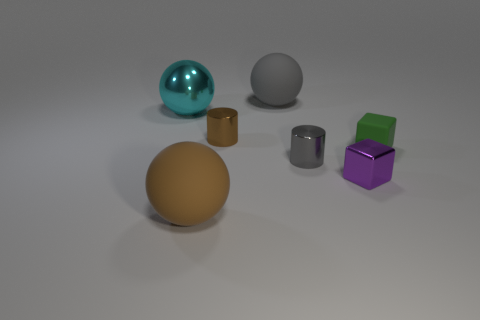Add 1 yellow metallic blocks. How many objects exist? 8 Subtract all cylinders. How many objects are left? 5 Subtract 0 blue blocks. How many objects are left? 7 Subtract all brown rubber balls. Subtract all metal cubes. How many objects are left? 5 Add 4 small gray shiny cylinders. How many small gray shiny cylinders are left? 5 Add 4 cyan spheres. How many cyan spheres exist? 5 